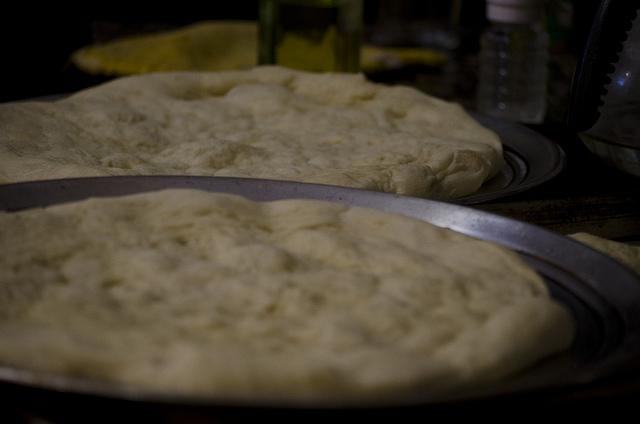How many bottles are in the picture?
Give a very brief answer. 2. How many pizzas are in the photo?
Give a very brief answer. 2. 